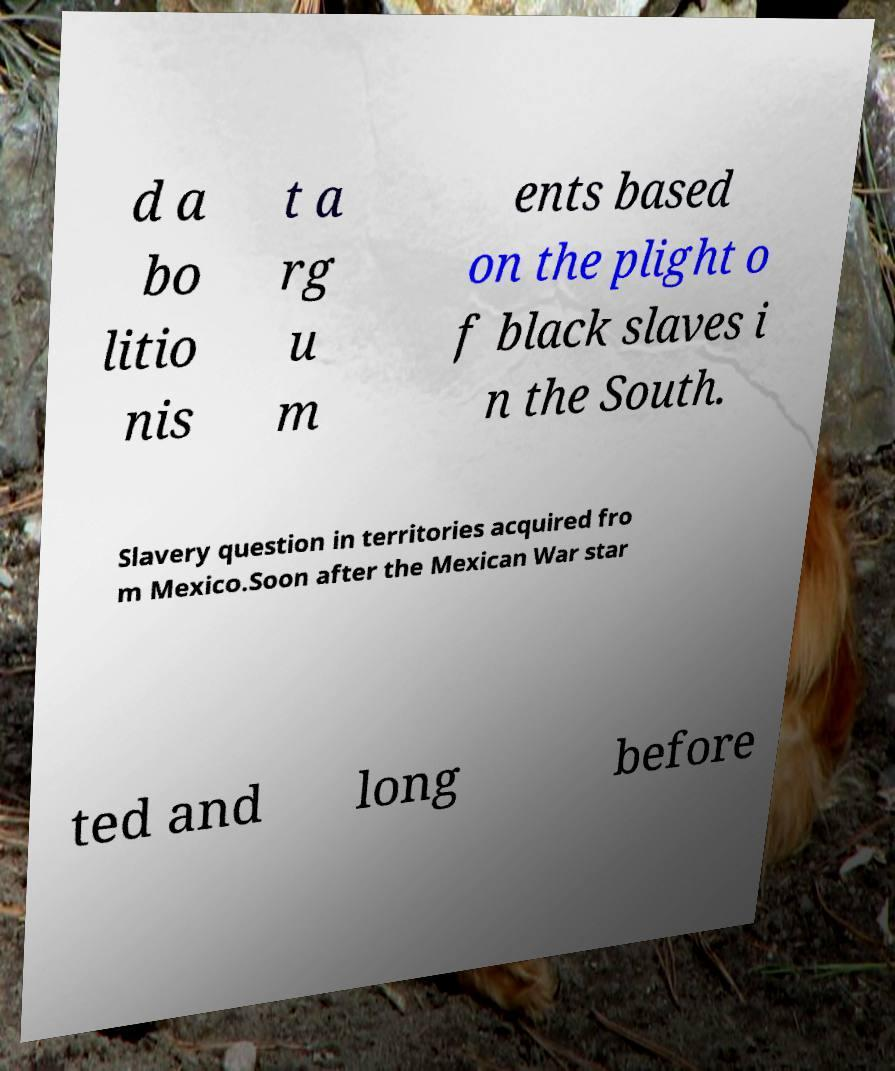Can you accurately transcribe the text from the provided image for me? d a bo litio nis t a rg u m ents based on the plight o f black slaves i n the South. Slavery question in territories acquired fro m Mexico.Soon after the Mexican War star ted and long before 